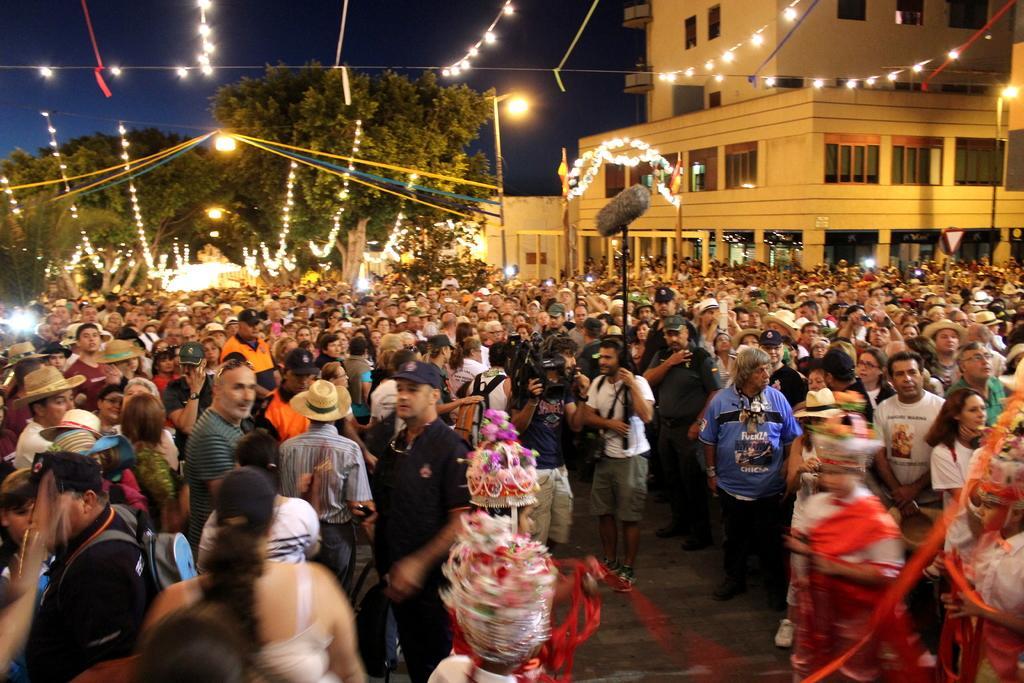Can you describe this image briefly? In the picture I can see a group of people on the road. I can see the small decorative string lights at the top of the picture. In the background, I can see the trees. I can see the building on the right side and there are glass windows of the building. I can see three persons in the costume and they are at the bottom of the picture. 